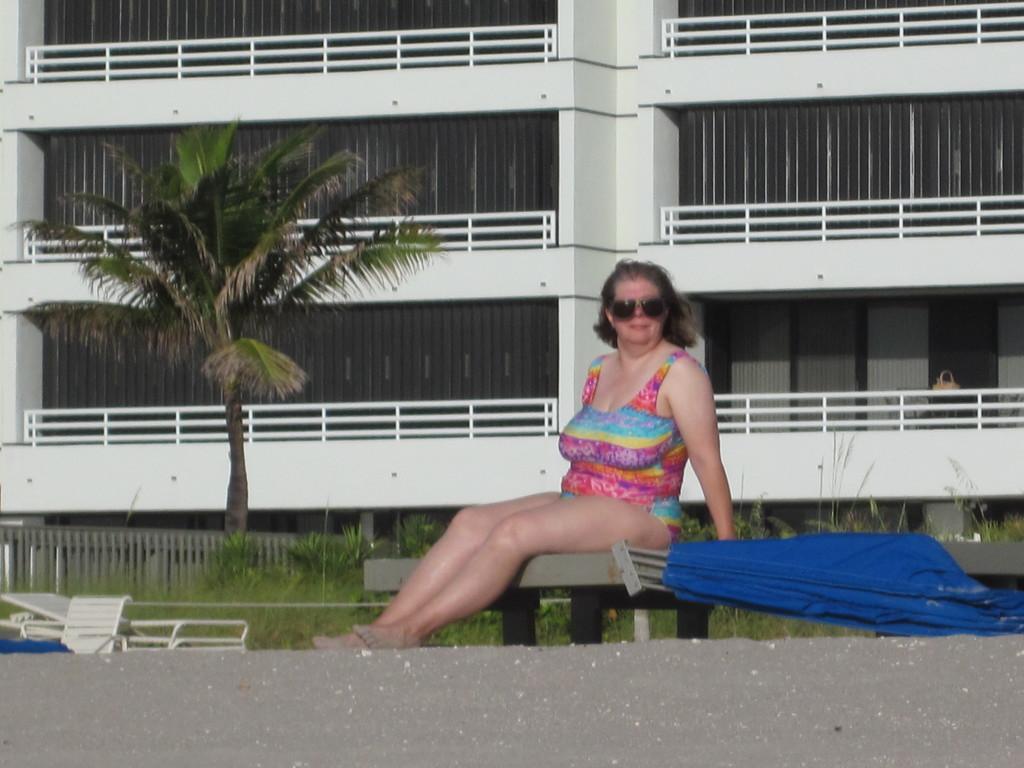Could you give a brief overview of what you see in this image? In this picture I can see there is a woman sitting on the flat surface, she is wearing a swimsuit and she is wearing glasses. There is a blue color object at right side and there are a few chairs at left side. There is a tree, grass and a huge building in the backdrop. 